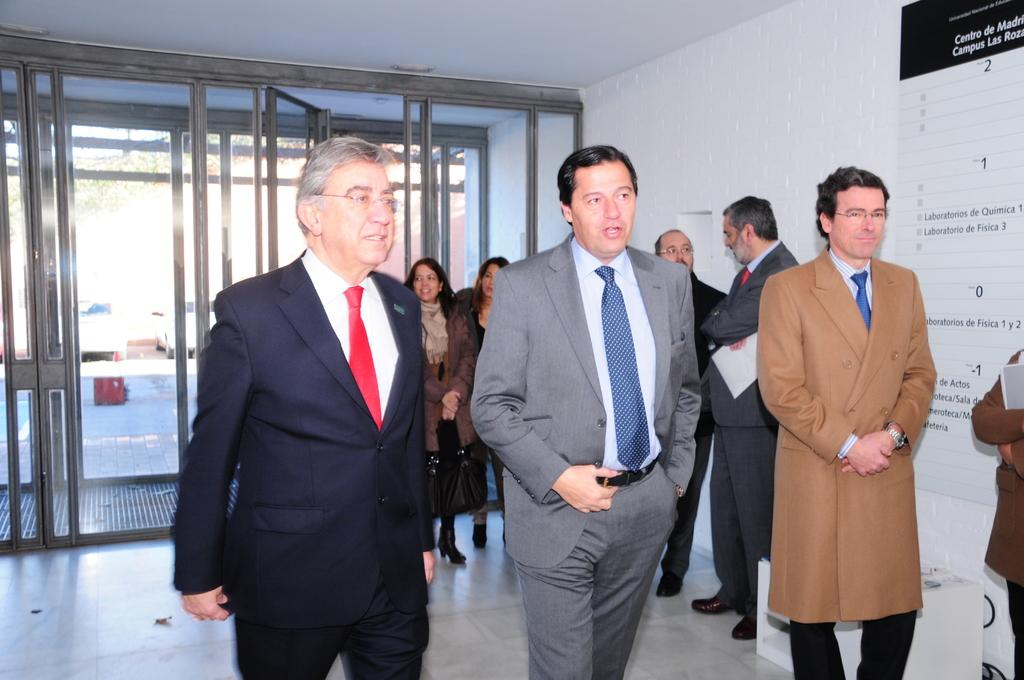Who or what can be seen in the image? There are people in the image. What is placed on the wall on the right side of the image? There is a board placed on the wall on the right side of the image. What object is present in the image that might be used for displaying or holding items? There is a stand in the image. What can be seen in the background of the image? Cars and doors are visible in the background of the image. What type of fish can be seen swimming in the image? There are no fish present in the image. How many people are seen crushing objects in the image? There is no indication of anyone crushing objects in the image. 